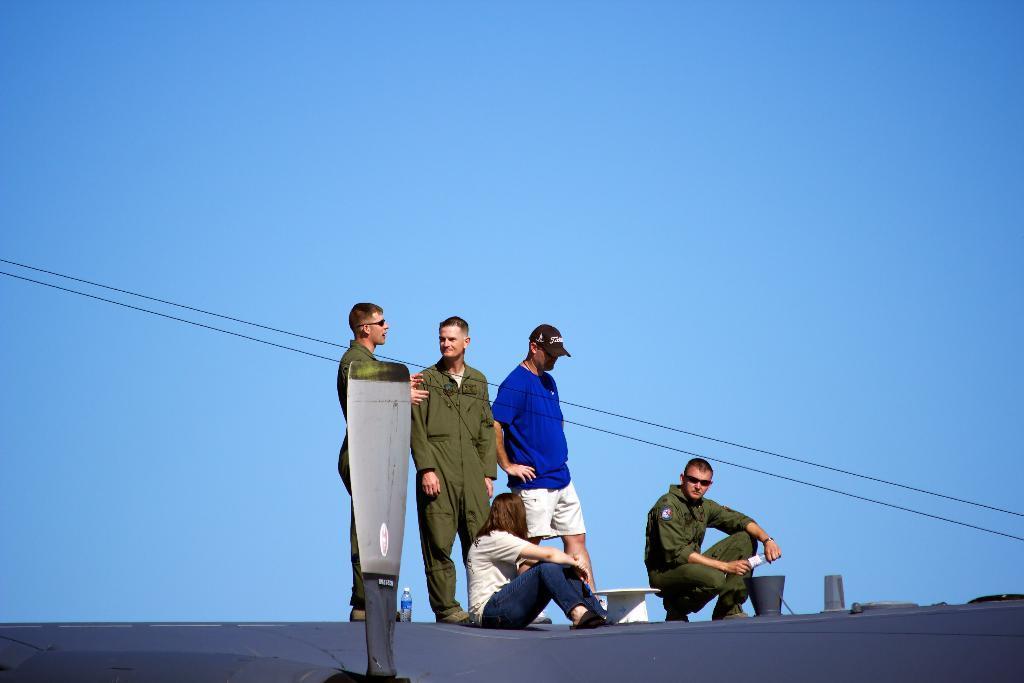In one or two sentences, can you explain what this image depicts? In the foreground there is a board. In the center of the picture there are four men and a woman may be on the roof of a building. In the center there are cables. Sky is clear and it is sunny. 